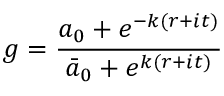Convert formula to latex. <formula><loc_0><loc_0><loc_500><loc_500>g = { \frac { a _ { 0 } + e ^ { - k ( r + i t ) } } { \bar { a } _ { 0 } + e ^ { k ( r + i t ) } } }</formula> 